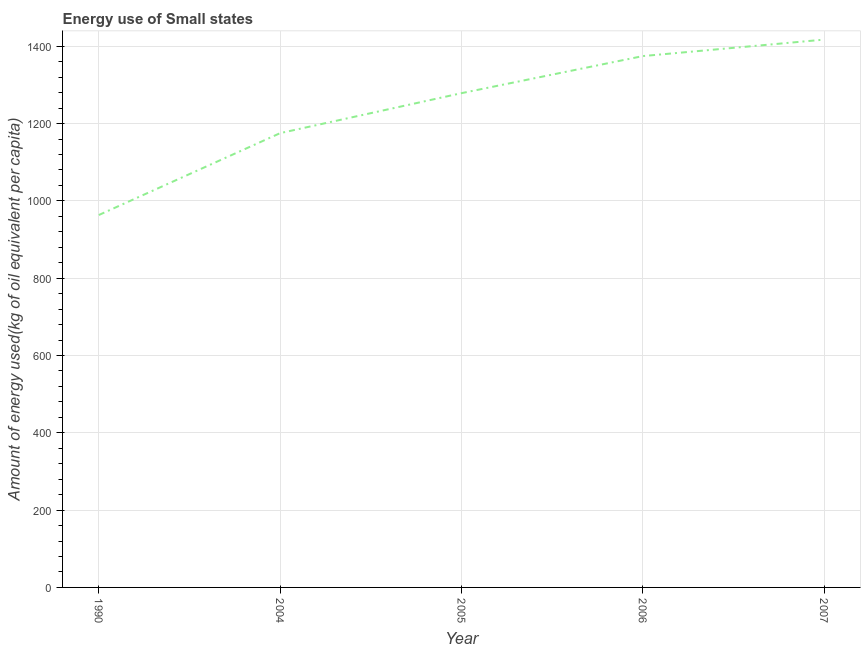What is the amount of energy used in 1990?
Give a very brief answer. 963.4. Across all years, what is the maximum amount of energy used?
Make the answer very short. 1417.19. Across all years, what is the minimum amount of energy used?
Keep it short and to the point. 963.4. In which year was the amount of energy used maximum?
Provide a succinct answer. 2007. What is the sum of the amount of energy used?
Keep it short and to the point. 6209.07. What is the difference between the amount of energy used in 2006 and 2007?
Offer a very short reply. -42.63. What is the average amount of energy used per year?
Your response must be concise. 1241.81. What is the median amount of energy used?
Keep it short and to the point. 1278.65. What is the ratio of the amount of energy used in 1990 to that in 2007?
Give a very brief answer. 0.68. What is the difference between the highest and the second highest amount of energy used?
Keep it short and to the point. 42.63. Is the sum of the amount of energy used in 2004 and 2005 greater than the maximum amount of energy used across all years?
Your answer should be compact. Yes. What is the difference between the highest and the lowest amount of energy used?
Provide a short and direct response. 453.8. Does the amount of energy used monotonically increase over the years?
Provide a succinct answer. Yes. How many lines are there?
Your response must be concise. 1. What is the difference between two consecutive major ticks on the Y-axis?
Your answer should be compact. 200. Does the graph contain any zero values?
Your answer should be compact. No. Does the graph contain grids?
Keep it short and to the point. Yes. What is the title of the graph?
Offer a terse response. Energy use of Small states. What is the label or title of the X-axis?
Your answer should be very brief. Year. What is the label or title of the Y-axis?
Your answer should be compact. Amount of energy used(kg of oil equivalent per capita). What is the Amount of energy used(kg of oil equivalent per capita) of 1990?
Offer a very short reply. 963.4. What is the Amount of energy used(kg of oil equivalent per capita) in 2004?
Give a very brief answer. 1175.26. What is the Amount of energy used(kg of oil equivalent per capita) of 2005?
Ensure brevity in your answer.  1278.65. What is the Amount of energy used(kg of oil equivalent per capita) of 2006?
Ensure brevity in your answer.  1374.57. What is the Amount of energy used(kg of oil equivalent per capita) in 2007?
Your answer should be very brief. 1417.19. What is the difference between the Amount of energy used(kg of oil equivalent per capita) in 1990 and 2004?
Provide a short and direct response. -211.86. What is the difference between the Amount of energy used(kg of oil equivalent per capita) in 1990 and 2005?
Your answer should be very brief. -315.26. What is the difference between the Amount of energy used(kg of oil equivalent per capita) in 1990 and 2006?
Provide a succinct answer. -411.17. What is the difference between the Amount of energy used(kg of oil equivalent per capita) in 1990 and 2007?
Give a very brief answer. -453.8. What is the difference between the Amount of energy used(kg of oil equivalent per capita) in 2004 and 2005?
Your response must be concise. -103.39. What is the difference between the Amount of energy used(kg of oil equivalent per capita) in 2004 and 2006?
Offer a terse response. -199.31. What is the difference between the Amount of energy used(kg of oil equivalent per capita) in 2004 and 2007?
Your response must be concise. -241.94. What is the difference between the Amount of energy used(kg of oil equivalent per capita) in 2005 and 2006?
Make the answer very short. -95.91. What is the difference between the Amount of energy used(kg of oil equivalent per capita) in 2005 and 2007?
Ensure brevity in your answer.  -138.54. What is the difference between the Amount of energy used(kg of oil equivalent per capita) in 2006 and 2007?
Offer a very short reply. -42.63. What is the ratio of the Amount of energy used(kg of oil equivalent per capita) in 1990 to that in 2004?
Provide a succinct answer. 0.82. What is the ratio of the Amount of energy used(kg of oil equivalent per capita) in 1990 to that in 2005?
Your response must be concise. 0.75. What is the ratio of the Amount of energy used(kg of oil equivalent per capita) in 1990 to that in 2006?
Your answer should be very brief. 0.7. What is the ratio of the Amount of energy used(kg of oil equivalent per capita) in 1990 to that in 2007?
Ensure brevity in your answer.  0.68. What is the ratio of the Amount of energy used(kg of oil equivalent per capita) in 2004 to that in 2005?
Offer a very short reply. 0.92. What is the ratio of the Amount of energy used(kg of oil equivalent per capita) in 2004 to that in 2006?
Make the answer very short. 0.85. What is the ratio of the Amount of energy used(kg of oil equivalent per capita) in 2004 to that in 2007?
Your answer should be very brief. 0.83. What is the ratio of the Amount of energy used(kg of oil equivalent per capita) in 2005 to that in 2006?
Offer a terse response. 0.93. What is the ratio of the Amount of energy used(kg of oil equivalent per capita) in 2005 to that in 2007?
Your answer should be very brief. 0.9. What is the ratio of the Amount of energy used(kg of oil equivalent per capita) in 2006 to that in 2007?
Ensure brevity in your answer.  0.97. 